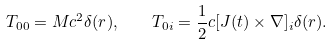Convert formula to latex. <formula><loc_0><loc_0><loc_500><loc_500>T _ { 0 0 } = M c ^ { 2 } \delta ( r ) , \quad T _ { 0 i } = \frac { 1 } { 2 } c [ J ( t ) \times \nabla ] _ { i } \delta ( r ) .</formula> 